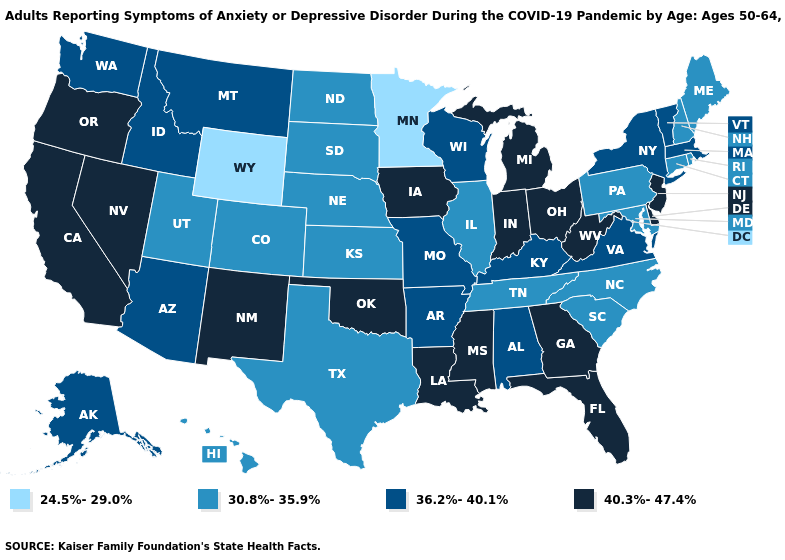Name the states that have a value in the range 40.3%-47.4%?
Answer briefly. California, Delaware, Florida, Georgia, Indiana, Iowa, Louisiana, Michigan, Mississippi, Nevada, New Jersey, New Mexico, Ohio, Oklahoma, Oregon, West Virginia. What is the value of Florida?
Write a very short answer. 40.3%-47.4%. What is the value of Massachusetts?
Answer briefly. 36.2%-40.1%. Which states hav the highest value in the MidWest?
Be succinct. Indiana, Iowa, Michigan, Ohio. Among the states that border Minnesota , does Iowa have the lowest value?
Concise answer only. No. What is the highest value in states that border Texas?
Concise answer only. 40.3%-47.4%. What is the lowest value in the MidWest?
Write a very short answer. 24.5%-29.0%. Name the states that have a value in the range 30.8%-35.9%?
Write a very short answer. Colorado, Connecticut, Hawaii, Illinois, Kansas, Maine, Maryland, Nebraska, New Hampshire, North Carolina, North Dakota, Pennsylvania, Rhode Island, South Carolina, South Dakota, Tennessee, Texas, Utah. How many symbols are there in the legend?
Write a very short answer. 4. Name the states that have a value in the range 36.2%-40.1%?
Be succinct. Alabama, Alaska, Arizona, Arkansas, Idaho, Kentucky, Massachusetts, Missouri, Montana, New York, Vermont, Virginia, Washington, Wisconsin. Name the states that have a value in the range 30.8%-35.9%?
Short answer required. Colorado, Connecticut, Hawaii, Illinois, Kansas, Maine, Maryland, Nebraska, New Hampshire, North Carolina, North Dakota, Pennsylvania, Rhode Island, South Carolina, South Dakota, Tennessee, Texas, Utah. What is the highest value in states that border Nebraska?
Write a very short answer. 40.3%-47.4%. Among the states that border North Dakota , which have the lowest value?
Quick response, please. Minnesota. Does Wyoming have the lowest value in the USA?
Write a very short answer. Yes. What is the lowest value in the MidWest?
Concise answer only. 24.5%-29.0%. 